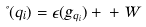Convert formula to latex. <formula><loc_0><loc_0><loc_500><loc_500>\Psi ( q _ { i } ) = \epsilon ( g _ { q _ { i } } ) + \Gamma + W</formula> 